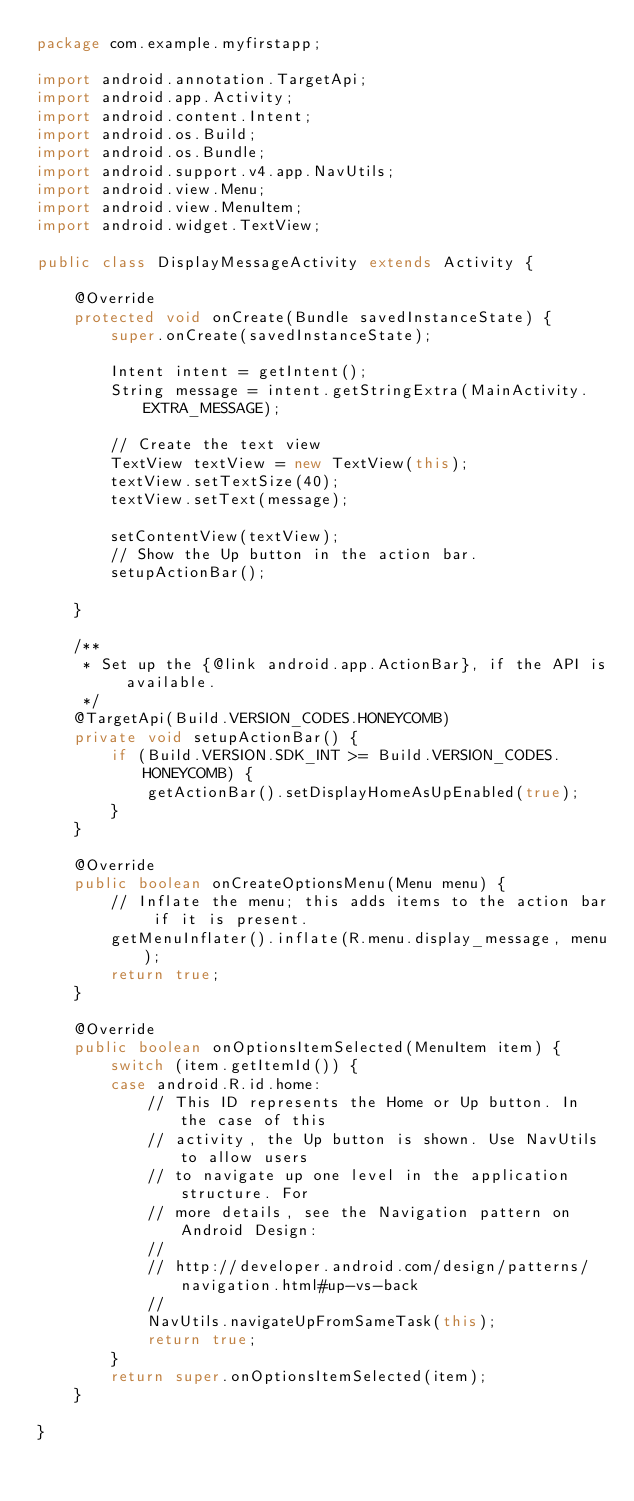Convert code to text. <code><loc_0><loc_0><loc_500><loc_500><_Java_>package com.example.myfirstapp;

import android.annotation.TargetApi;
import android.app.Activity;
import android.content.Intent;
import android.os.Build;
import android.os.Bundle;
import android.support.v4.app.NavUtils;
import android.view.Menu;
import android.view.MenuItem;
import android.widget.TextView;

public class DisplayMessageActivity extends Activity {

	@Override
	protected void onCreate(Bundle savedInstanceState) {
		super.onCreate(savedInstanceState);

		Intent intent = getIntent();
		String message = intent.getStringExtra(MainActivity.EXTRA_MESSAGE);

	    // Create the text view
	    TextView textView = new TextView(this);
	    textView.setTextSize(40);
	    textView.setText(message);

		setContentView(textView);
		// Show the Up button in the action bar.
		setupActionBar();
		
	}

	/**
	 * Set up the {@link android.app.ActionBar}, if the API is available.
	 */
	@TargetApi(Build.VERSION_CODES.HONEYCOMB)
	private void setupActionBar() {
		if (Build.VERSION.SDK_INT >= Build.VERSION_CODES.HONEYCOMB) {
			getActionBar().setDisplayHomeAsUpEnabled(true);
		}
	}

	@Override
	public boolean onCreateOptionsMenu(Menu menu) {
		// Inflate the menu; this adds items to the action bar if it is present.
		getMenuInflater().inflate(R.menu.display_message, menu);
		return true;
	}

	@Override
	public boolean onOptionsItemSelected(MenuItem item) {
		switch (item.getItemId()) {
		case android.R.id.home:
			// This ID represents the Home or Up button. In the case of this
			// activity, the Up button is shown. Use NavUtils to allow users
			// to navigate up one level in the application structure. For
			// more details, see the Navigation pattern on Android Design:
			//
			// http://developer.android.com/design/patterns/navigation.html#up-vs-back
			//
			NavUtils.navigateUpFromSameTask(this);
			return true;
		}
		return super.onOptionsItemSelected(item);
	}

}
</code> 